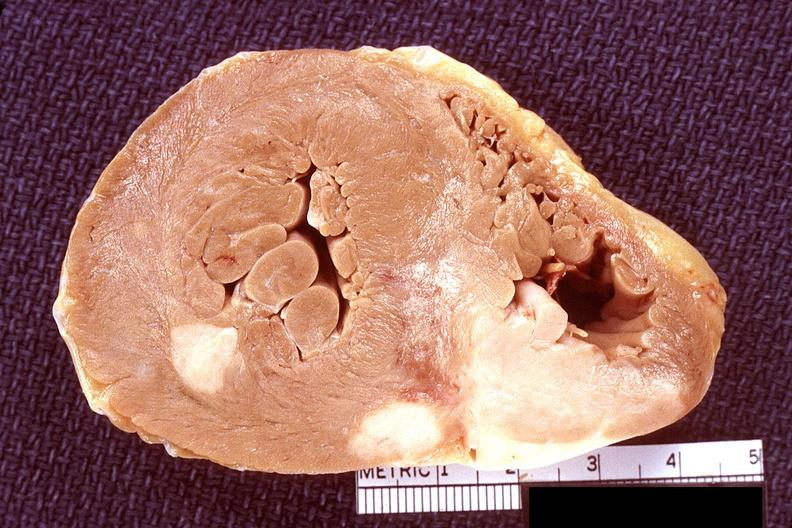does carcinomatosis show heart, lymphoma?
Answer the question using a single word or phrase. No 